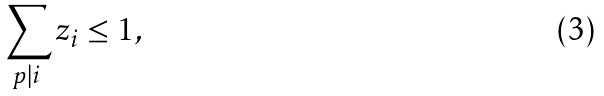<formula> <loc_0><loc_0><loc_500><loc_500>\sum _ { p | i } z _ { i } \leq 1 ,</formula> 